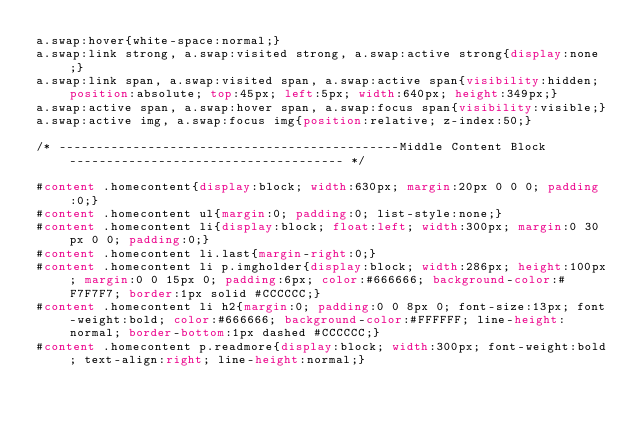Convert code to text. <code><loc_0><loc_0><loc_500><loc_500><_CSS_>a.swap:hover{white-space:normal;}
a.swap:link strong, a.swap:visited strong, a.swap:active strong{display:none;}
a.swap:link span, a.swap:visited span, a.swap:active span{visibility:hidden; position:absolute; top:45px; left:5px; width:640px; height:349px;}
a.swap:active span, a.swap:hover span, a.swap:focus span{visibility:visible;}
a.swap:active img, a.swap:focus img{position:relative; z-index:50;}

/* ----------------------------------------------Middle Content Block------------------------------------- */

#content .homecontent{display:block; width:630px; margin:20px 0 0 0; padding:0;}
#content .homecontent ul{margin:0; padding:0; list-style:none;}
#content .homecontent li{display:block; float:left; width:300px; margin:0 30px 0 0; padding:0;}
#content .homecontent li.last{margin-right:0;}
#content .homecontent li p.imgholder{display:block; width:286px; height:100px; margin:0 0 15px 0; padding:6px; color:#666666; background-color:#F7F7F7; border:1px solid #CCCCCC;}
#content .homecontent li h2{margin:0; padding:0 0 8px 0; font-size:13px; font-weight:bold; color:#666666; background-color:#FFFFFF; line-height:normal; border-bottom:1px dashed #CCCCCC;}
#content .homecontent p.readmore{display:block; width:300px; font-weight:bold; text-align:right; line-height:normal;}</code> 